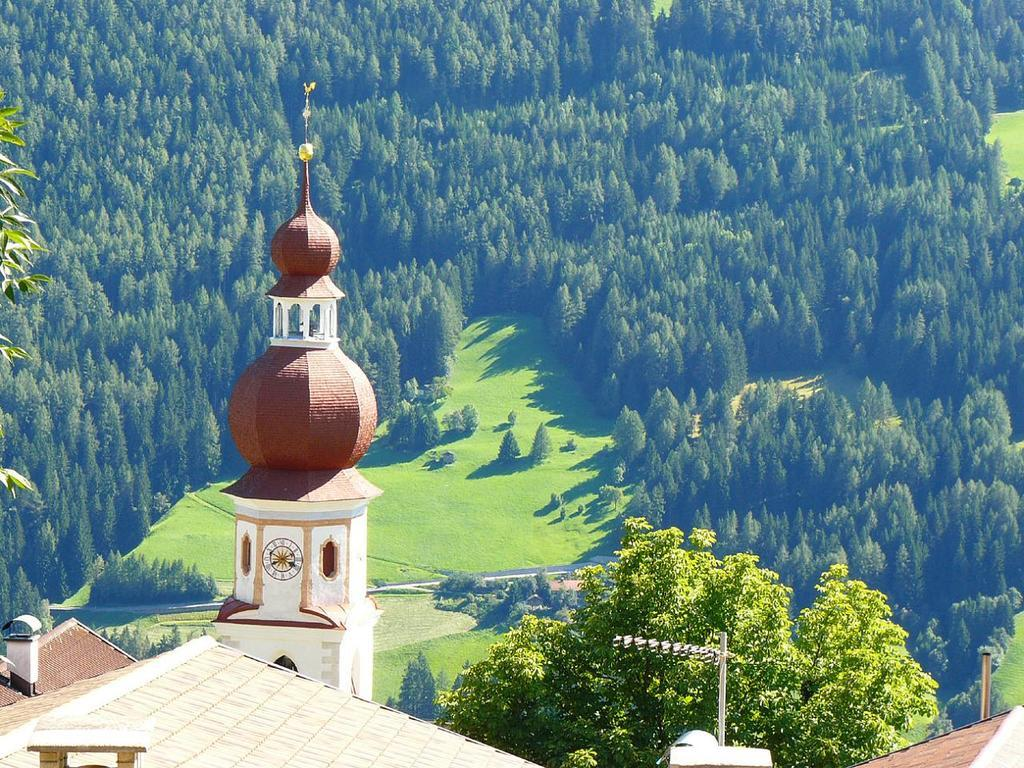What is the tall structure in the image? There is a clock tower in the image. What type of small structure can be seen in the image? There is a shed in the image. What type of large structure is present in the image? There is a building in the image. What are the long, thin objects in the image? There are poles in the image. What type of natural vegetation is visible in the image? There are trees in the image. What part of the environment is visible in the image? The ground is visible in the image. What type of instrument is being played by the fish in the image? There are no fish or instruments present in the image. How many horses can be seen in the image? There are no horses present in the image. 